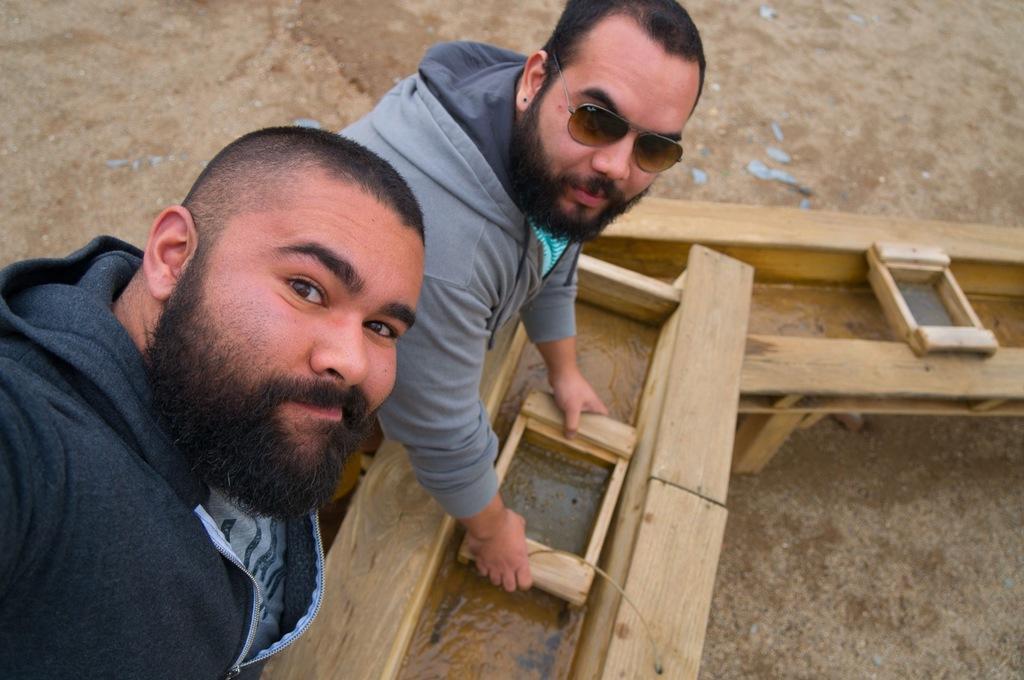Describe this image in one or two sentences. In this picture we can see two men smiling were a man wore goggles and holding a wooden object with his hands, water and in the background we can see the ground. 